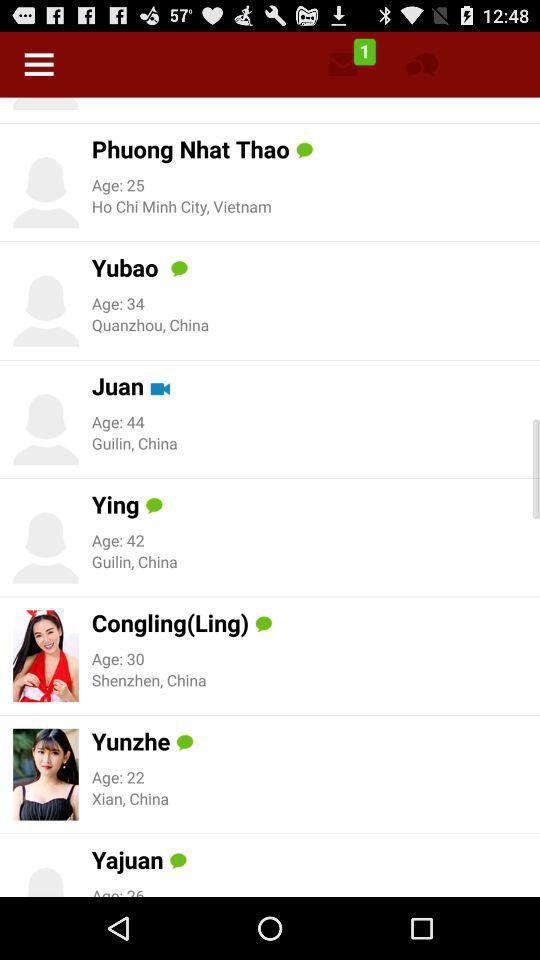Which user has minimum age?
When the provided information is insufficient, respond with <no answer>. <no answer> 